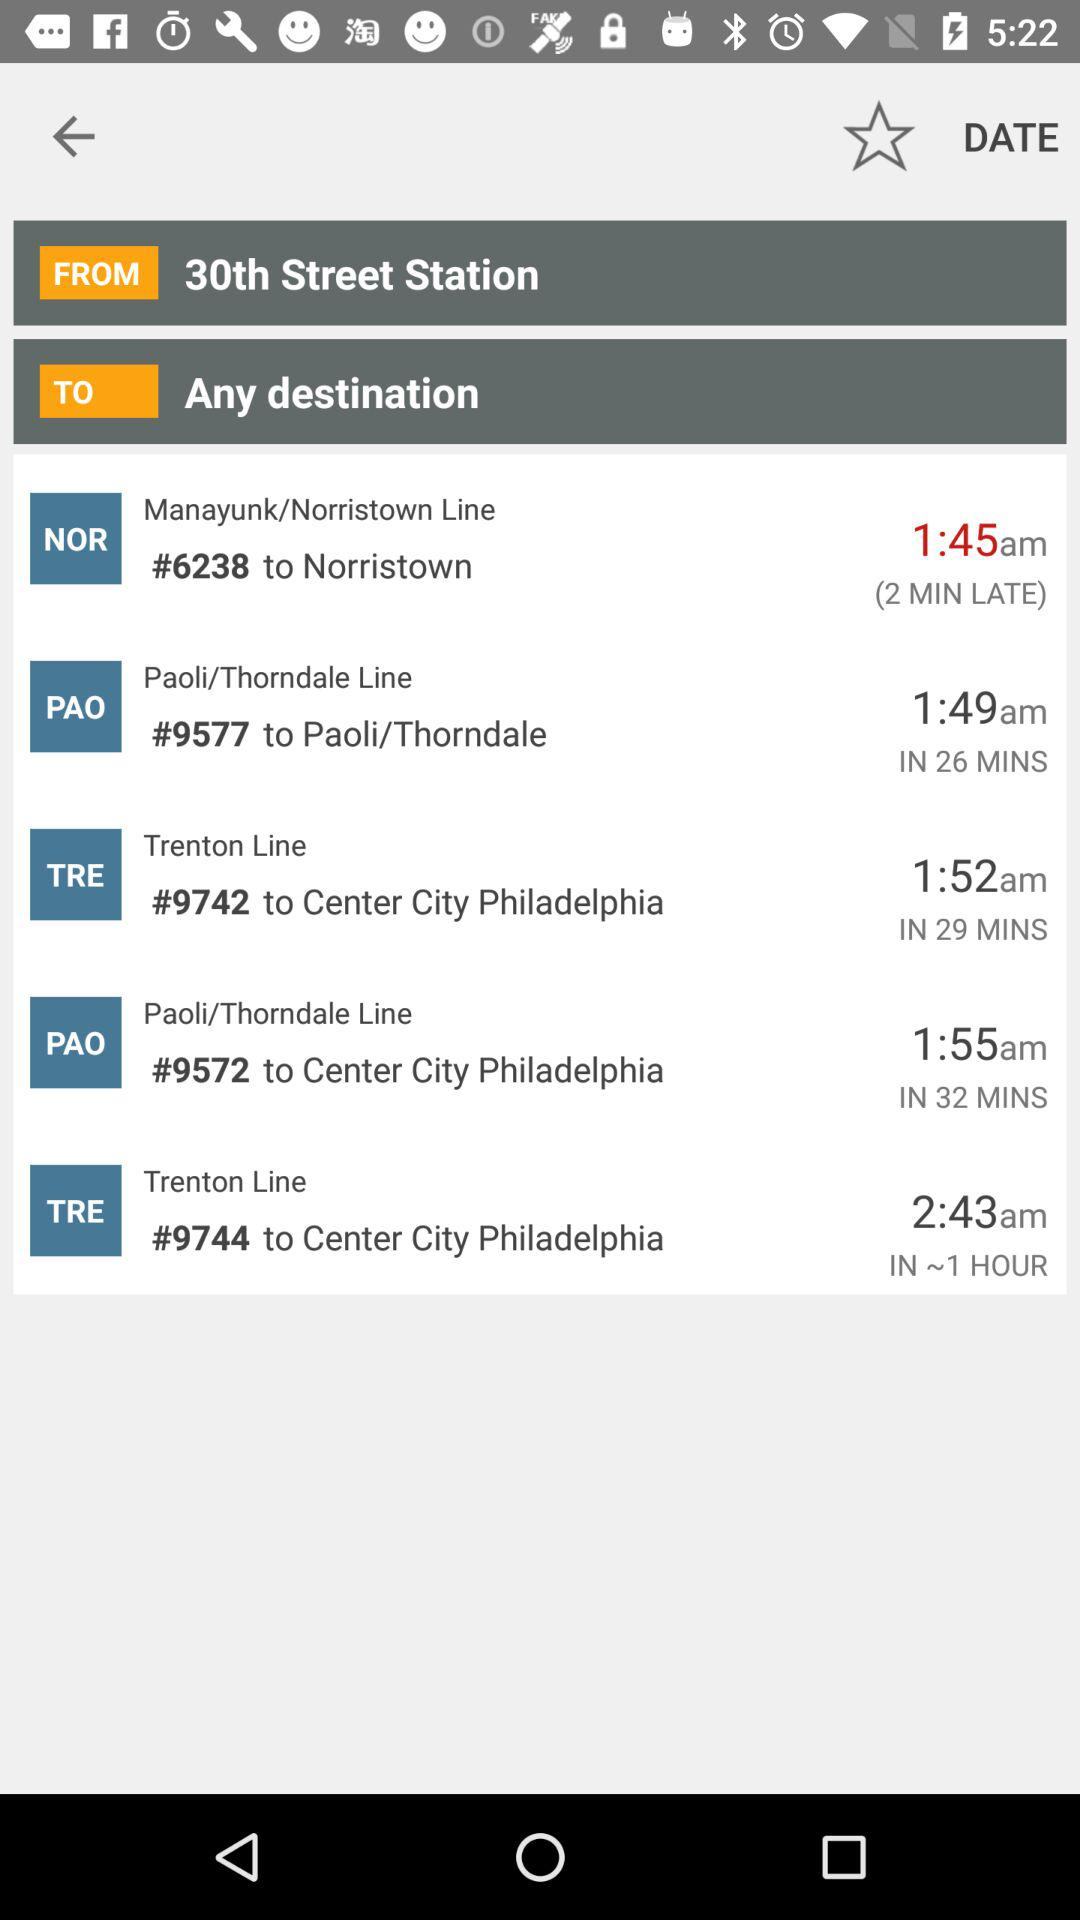What's the departure time of the train #9572 going to Center City Philadelphia on the Paoli/Trenton Line? The departure time of the train is 1:55 a.m. 